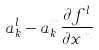<formula> <loc_0><loc_0><loc_500><loc_500>a _ { k } ^ { l } - a _ { k } ^ { m } \frac { \partial f ^ { l } } { \partial x ^ { m } }</formula> 